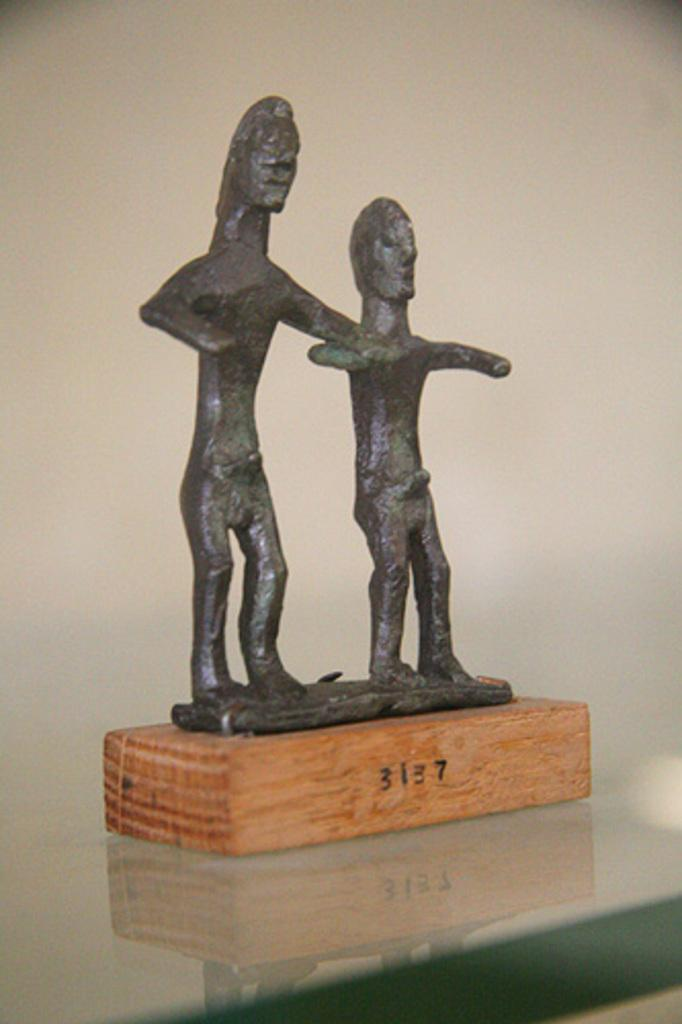What is the main subject of the image? There is a sculpture in the image. What is the sculpture resting on? The sculpture is on a wooden base. What other object can be seen in the image? There is a glass in the image. What color is the background of the image? The background of the image is white. Can you tell me how many partners are visible in the image? There are no partners present in the image; it features a sculpture on a wooden base, a glass, and a white background. Is there a light bulb illuminating the sculpture in the image? There is no light bulb visible in the image; it only shows the sculpture, glass, and white background. 